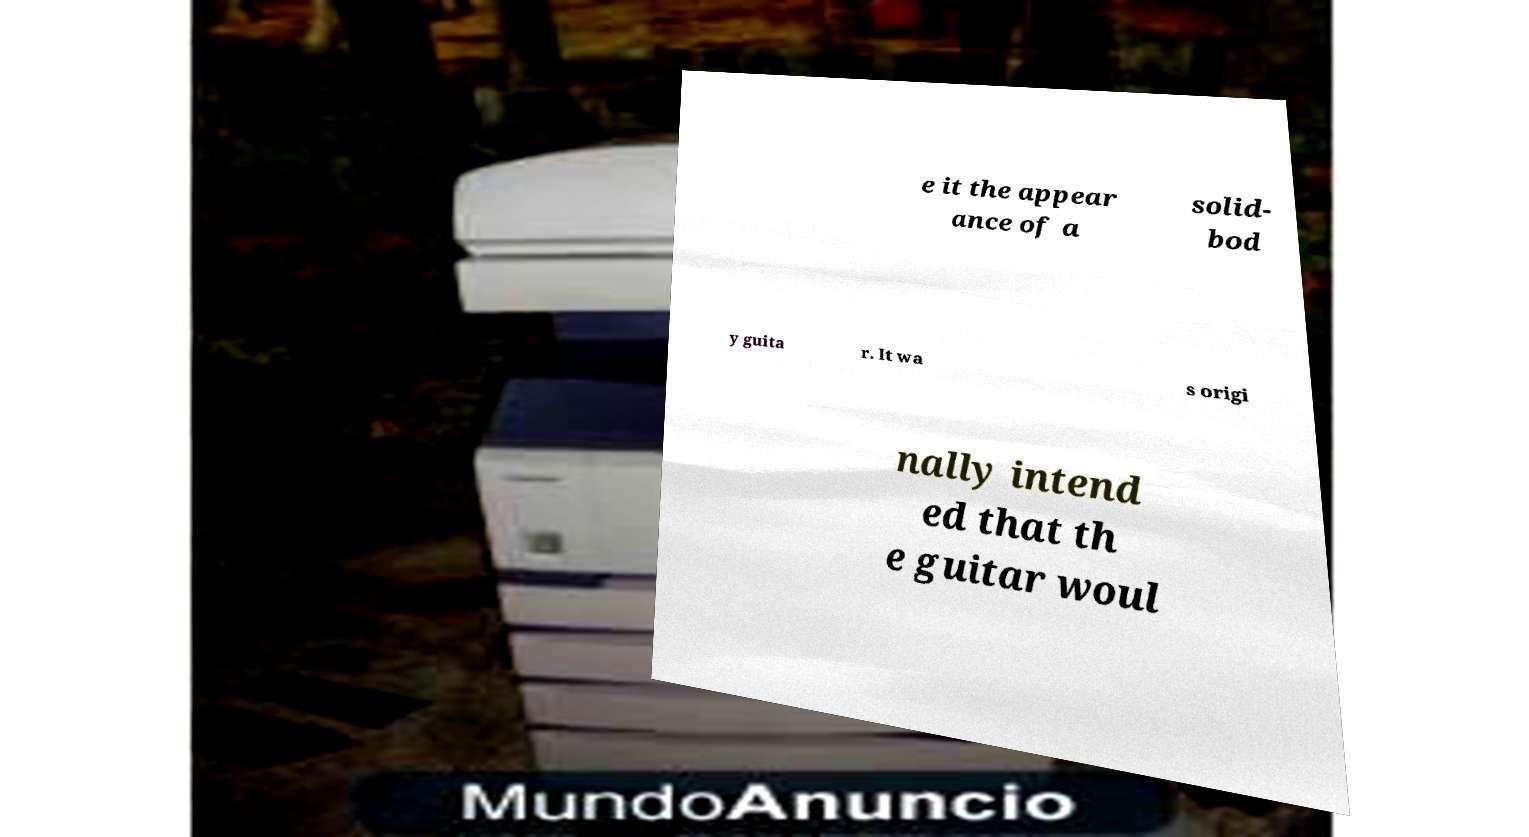Could you assist in decoding the text presented in this image and type it out clearly? e it the appear ance of a solid- bod y guita r. It wa s origi nally intend ed that th e guitar woul 